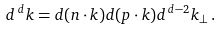Convert formula to latex. <formula><loc_0><loc_0><loc_500><loc_500>d ^ { \, d } k = d ( n \cdot k ) d ( p \cdot k ) d ^ { \, d - 2 } k _ { \perp } \, .</formula> 